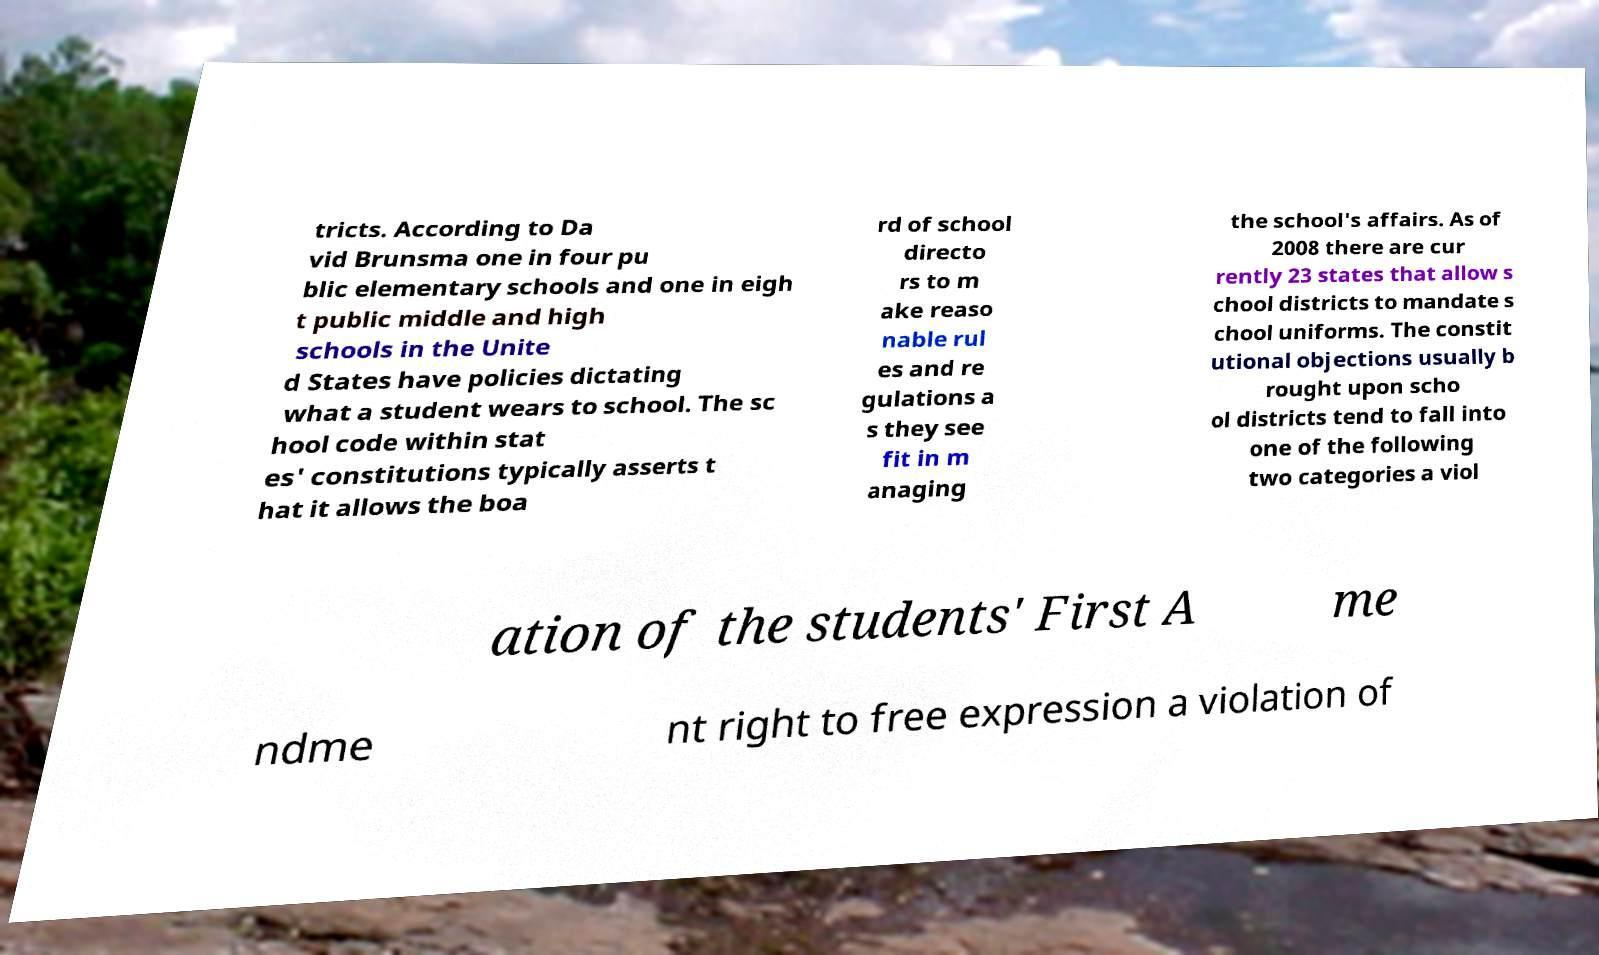There's text embedded in this image that I need extracted. Can you transcribe it verbatim? tricts. According to Da vid Brunsma one in four pu blic elementary schools and one in eigh t public middle and high schools in the Unite d States have policies dictating what a student wears to school. The sc hool code within stat es' constitutions typically asserts t hat it allows the boa rd of school directo rs to m ake reaso nable rul es and re gulations a s they see fit in m anaging the school's affairs. As of 2008 there are cur rently 23 states that allow s chool districts to mandate s chool uniforms. The constit utional objections usually b rought upon scho ol districts tend to fall into one of the following two categories a viol ation of the students' First A me ndme nt right to free expression a violation of 